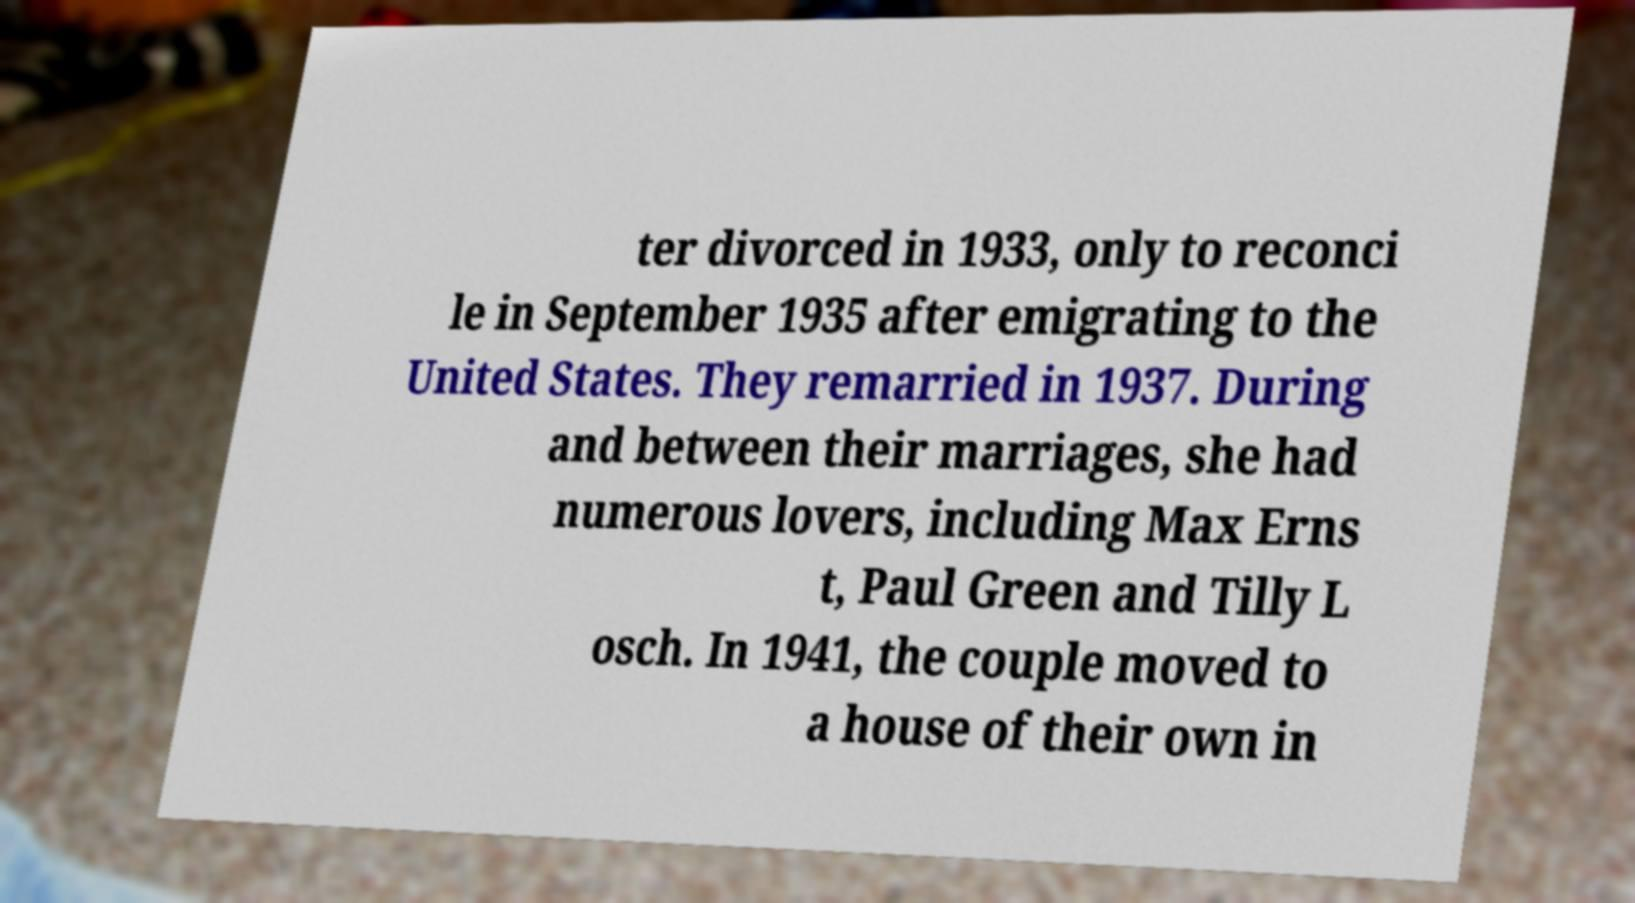Could you assist in decoding the text presented in this image and type it out clearly? ter divorced in 1933, only to reconci le in September 1935 after emigrating to the United States. They remarried in 1937. During and between their marriages, she had numerous lovers, including Max Erns t, Paul Green and Tilly L osch. In 1941, the couple moved to a house of their own in 